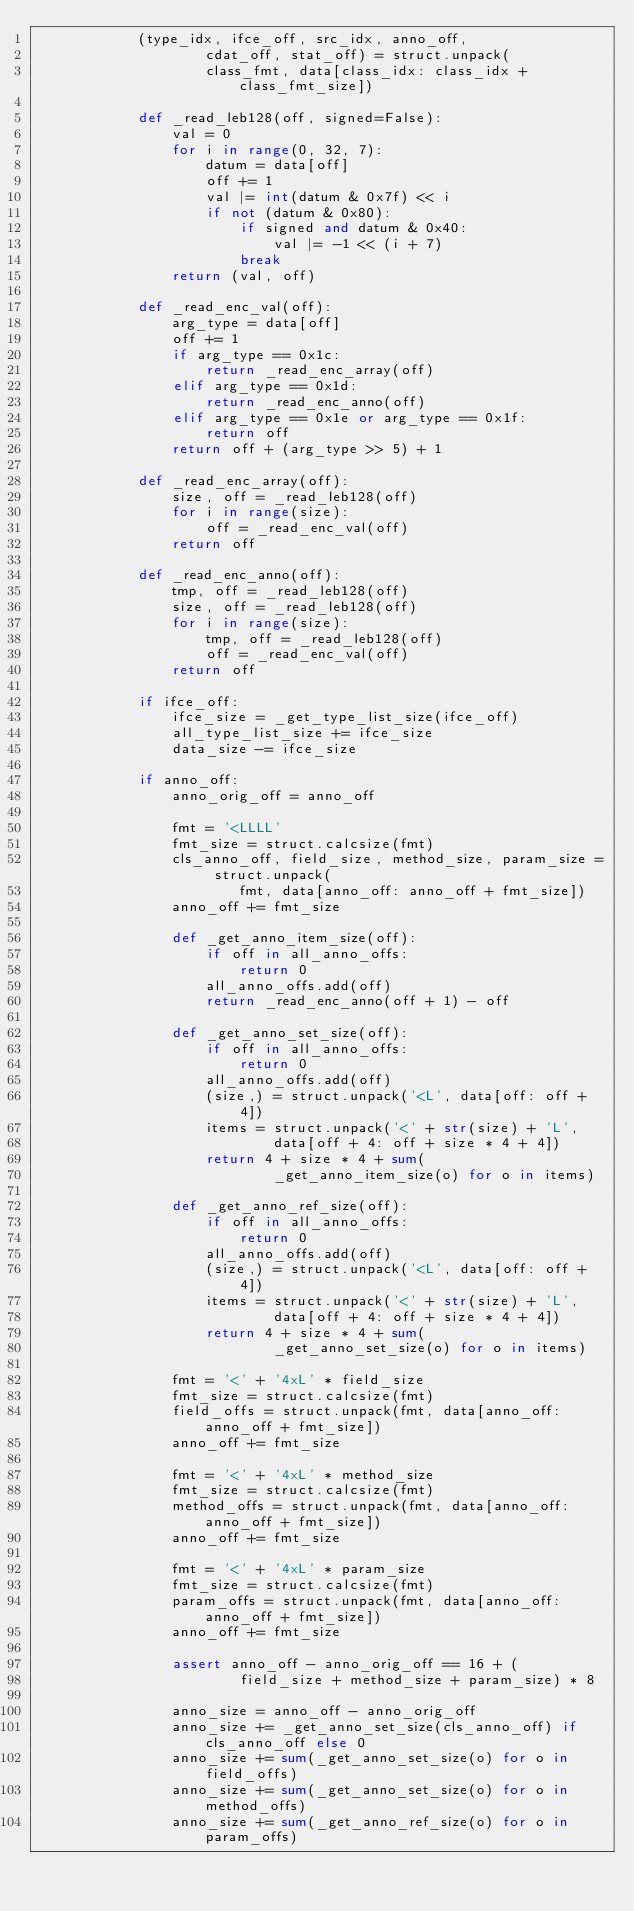Convert code to text. <code><loc_0><loc_0><loc_500><loc_500><_Python_>            (type_idx, ifce_off, src_idx, anno_off,
                    cdat_off, stat_off) = struct.unpack(
                    class_fmt, data[class_idx: class_idx + class_fmt_size])

            def _read_leb128(off, signed=False):
                val = 0
                for i in range(0, 32, 7):
                    datum = data[off]
                    off += 1
                    val |= int(datum & 0x7f) << i
                    if not (datum & 0x80):
                        if signed and datum & 0x40:
                            val |= -1 << (i + 7)
                        break
                return (val, off)

            def _read_enc_val(off):
                arg_type = data[off]
                off += 1
                if arg_type == 0x1c:
                    return _read_enc_array(off)
                elif arg_type == 0x1d:
                    return _read_enc_anno(off)
                elif arg_type == 0x1e or arg_type == 0x1f:
                    return off
                return off + (arg_type >> 5) + 1

            def _read_enc_array(off):
                size, off = _read_leb128(off)
                for i in range(size):
                    off = _read_enc_val(off)
                return off

            def _read_enc_anno(off):
                tmp, off = _read_leb128(off)
                size, off = _read_leb128(off)
                for i in range(size):
                    tmp, off = _read_leb128(off)
                    off = _read_enc_val(off)
                return off

            if ifce_off:
                ifce_size = _get_type_list_size(ifce_off)
                all_type_list_size += ifce_size
                data_size -= ifce_size

            if anno_off:
                anno_orig_off = anno_off

                fmt = '<LLLL'
                fmt_size = struct.calcsize(fmt)
                cls_anno_off, field_size, method_size, param_size = struct.unpack(
                        fmt, data[anno_off: anno_off + fmt_size])
                anno_off += fmt_size

                def _get_anno_item_size(off):
                    if off in all_anno_offs:
                        return 0
                    all_anno_offs.add(off)
                    return _read_enc_anno(off + 1) - off

                def _get_anno_set_size(off):
                    if off in all_anno_offs:
                        return 0
                    all_anno_offs.add(off)
                    (size,) = struct.unpack('<L', data[off: off + 4])
                    items = struct.unpack('<' + str(size) + 'L',
                            data[off + 4: off + size * 4 + 4])
                    return 4 + size * 4 + sum(
                            _get_anno_item_size(o) for o in items)

                def _get_anno_ref_size(off):
                    if off in all_anno_offs:
                        return 0
                    all_anno_offs.add(off)
                    (size,) = struct.unpack('<L', data[off: off + 4])
                    items = struct.unpack('<' + str(size) + 'L',
                            data[off + 4: off + size * 4 + 4])
                    return 4 + size * 4 + sum(
                            _get_anno_set_size(o) for o in items)

                fmt = '<' + '4xL' * field_size
                fmt_size = struct.calcsize(fmt)
                field_offs = struct.unpack(fmt, data[anno_off: anno_off + fmt_size])
                anno_off += fmt_size

                fmt = '<' + '4xL' * method_size
                fmt_size = struct.calcsize(fmt)
                method_offs = struct.unpack(fmt, data[anno_off: anno_off + fmt_size])
                anno_off += fmt_size

                fmt = '<' + '4xL' * param_size
                fmt_size = struct.calcsize(fmt)
                param_offs = struct.unpack(fmt, data[anno_off: anno_off + fmt_size])
                anno_off += fmt_size

                assert anno_off - anno_orig_off == 16 + (
                        field_size + method_size + param_size) * 8

                anno_size = anno_off - anno_orig_off
                anno_size += _get_anno_set_size(cls_anno_off) if cls_anno_off else 0
                anno_size += sum(_get_anno_set_size(o) for o in field_offs)
                anno_size += sum(_get_anno_set_size(o) for o in method_offs)
                anno_size += sum(_get_anno_ref_size(o) for o in param_offs)
</code> 